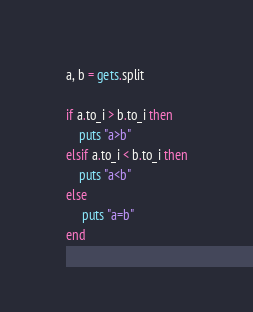<code> <loc_0><loc_0><loc_500><loc_500><_Ruby_>a, b = gets.split

if a.to_i > b.to_i then
    puts "a>b"
elsif a.to_i < b.to_i then
    puts "a<b"
else
     puts "a=b"
end</code> 